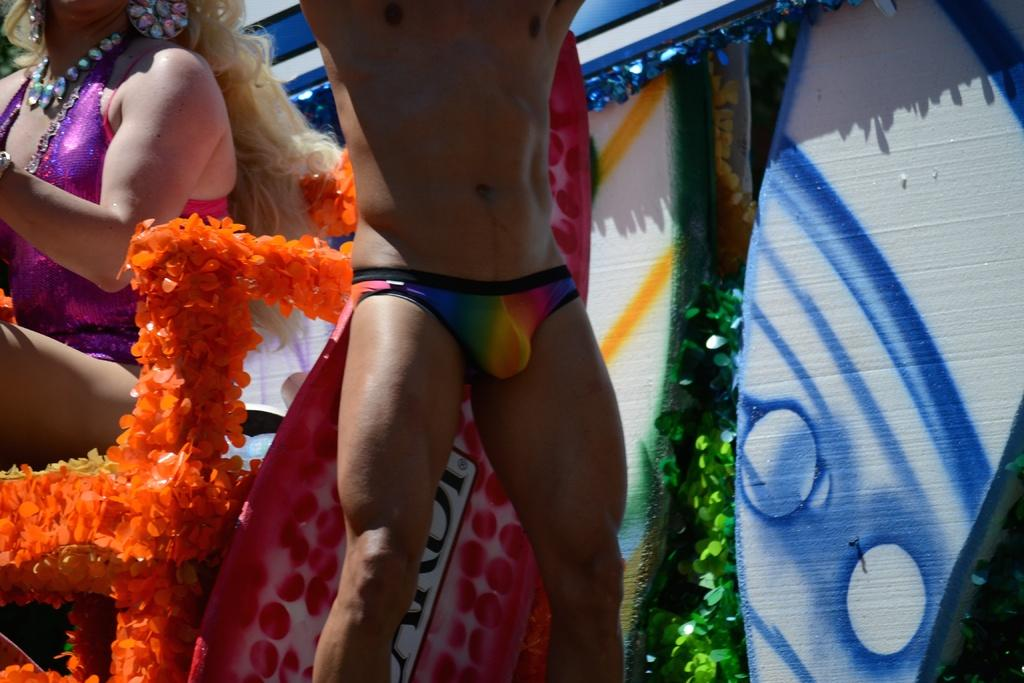What is the man doing in the image? The man is standing in the image. What is the woman doing in the image? The woman is sitting on a chair in the image. What objects are visible at the back of the image? There are surfboards and plants at the back of the image. What type of worm can be seen crawling on the man's shirt in the image? There is no worm present in the image; the man's shirt is free of any crawling creatures. 